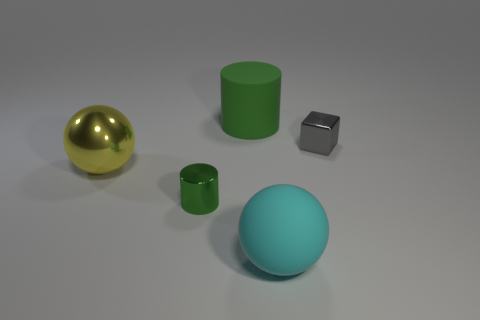Add 1 small yellow rubber blocks. How many objects exist? 6 Subtract 1 spheres. How many spheres are left? 1 Subtract all cubes. How many objects are left? 4 Subtract all brown cylinders. Subtract all brown blocks. How many cylinders are left? 2 Subtract all green cylinders. How many yellow spheres are left? 1 Subtract all purple cylinders. Subtract all cubes. How many objects are left? 4 Add 3 yellow shiny spheres. How many yellow shiny spheres are left? 4 Add 5 spheres. How many spheres exist? 7 Subtract 0 gray cylinders. How many objects are left? 5 